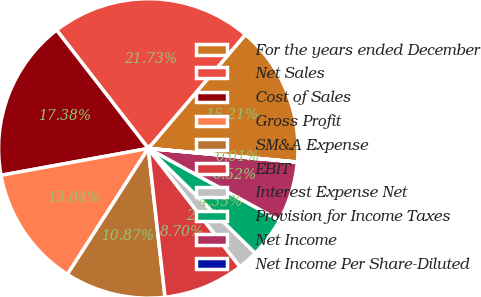<chart> <loc_0><loc_0><loc_500><loc_500><pie_chart><fcel>For the years ended December<fcel>Net Sales<fcel>Cost of Sales<fcel>Gross Profit<fcel>SM&A Expense<fcel>EBIT<fcel>Interest Expense Net<fcel>Provision for Income Taxes<fcel>Net Income<fcel>Net Income Per Share-Diluted<nl><fcel>15.21%<fcel>21.73%<fcel>17.38%<fcel>13.04%<fcel>10.87%<fcel>8.7%<fcel>2.18%<fcel>4.35%<fcel>6.52%<fcel>0.01%<nl></chart> 